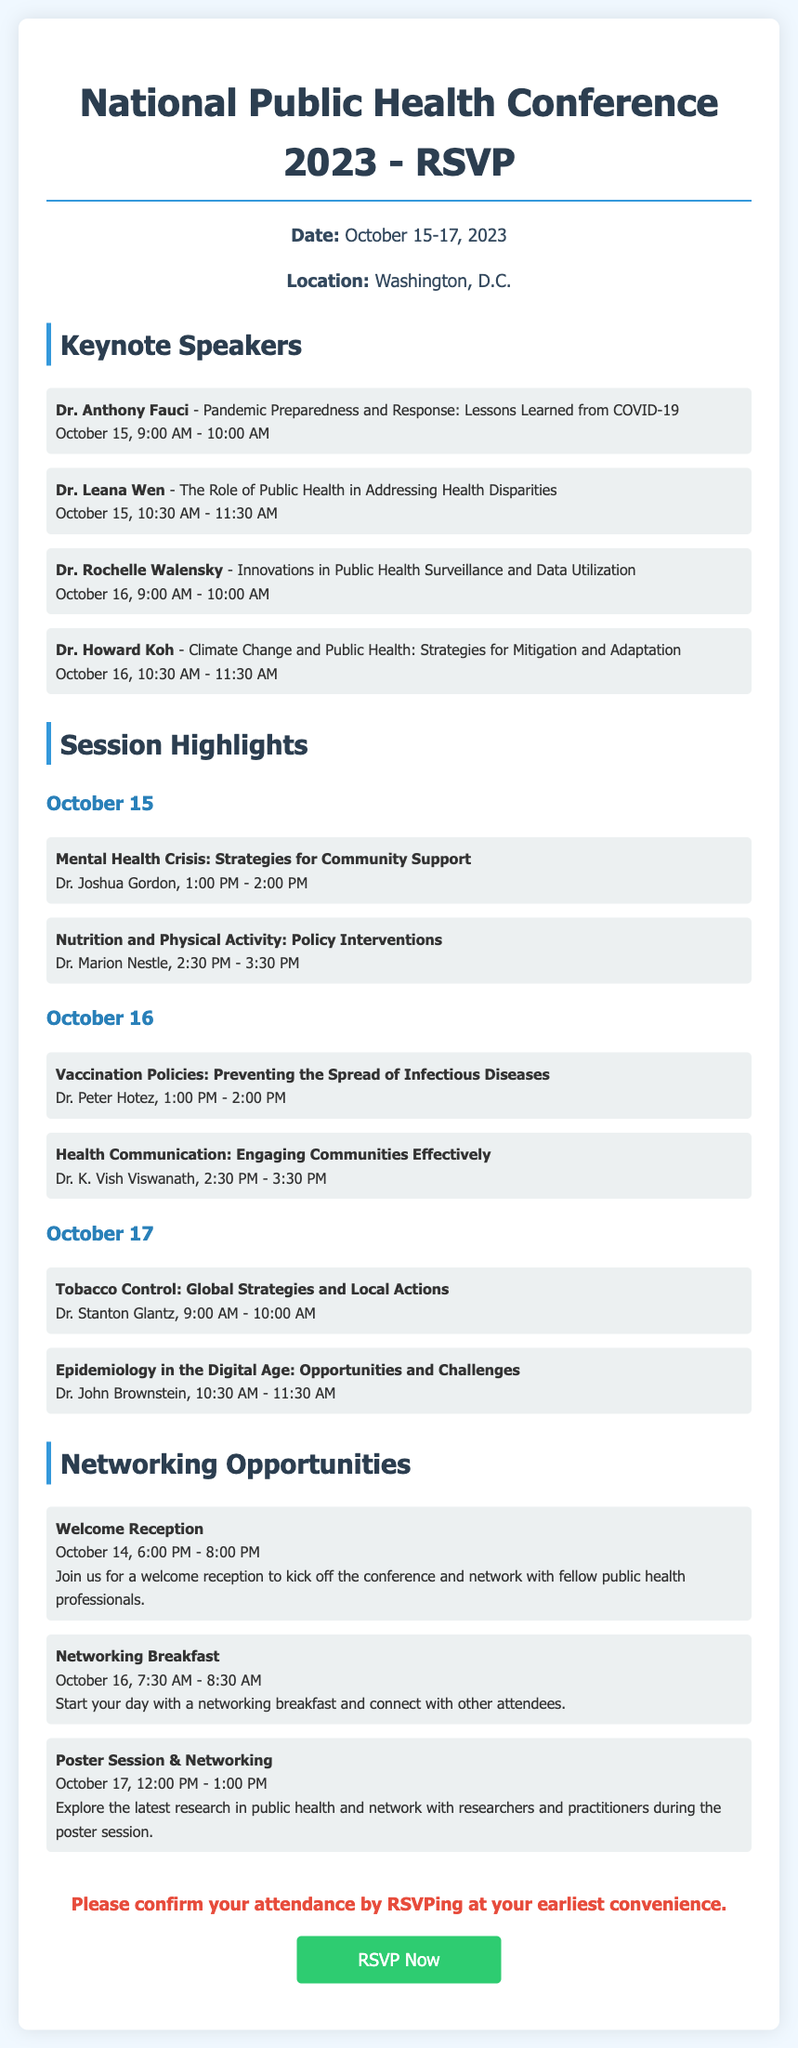What is the date of the National Public Health Conference? The date is mentioned in the document as October 15-17, 2023.
Answer: October 15-17, 2023 Who is the keynote speaker discussing pandemic preparedness? The document lists Dr. Anthony Fauci as the speaker for this topic on October 15.
Answer: Dr. Anthony Fauci What time does the welcome reception start? The welcome reception details show that it starts at 6:00 PM on October 14.
Answer: 6:00 PM How many keynote speakers are listed in the document? The document provides a list of four keynote speakers.
Answer: Four What is the focus of Dr. Leana Wen's keynote speech? The document states that Dr. Leana Wen will talk about addressing health disparities.
Answer: Addressing health disparities What session is scheduled for October 16 at 1:00 PM? The document includes the session on vaccination policies led by Dr. Peter Hotez at 1:00 PM.
Answer: Vaccination Policies: Preventing the Spread of Infectious Diseases What networking opportunity occurs on October 16? The document specifies a networking breakfast takes place on that date from 7:30 AM to 8:30 AM.
Answer: Networking Breakfast Who will be speaking about climate change and public health? According to the document, Dr. Howard Koh is the speaker for this subject on October 16.
Answer: Dr. Howard Koh 